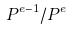Convert formula to latex. <formula><loc_0><loc_0><loc_500><loc_500>P ^ { e - 1 } / P ^ { e }</formula> 